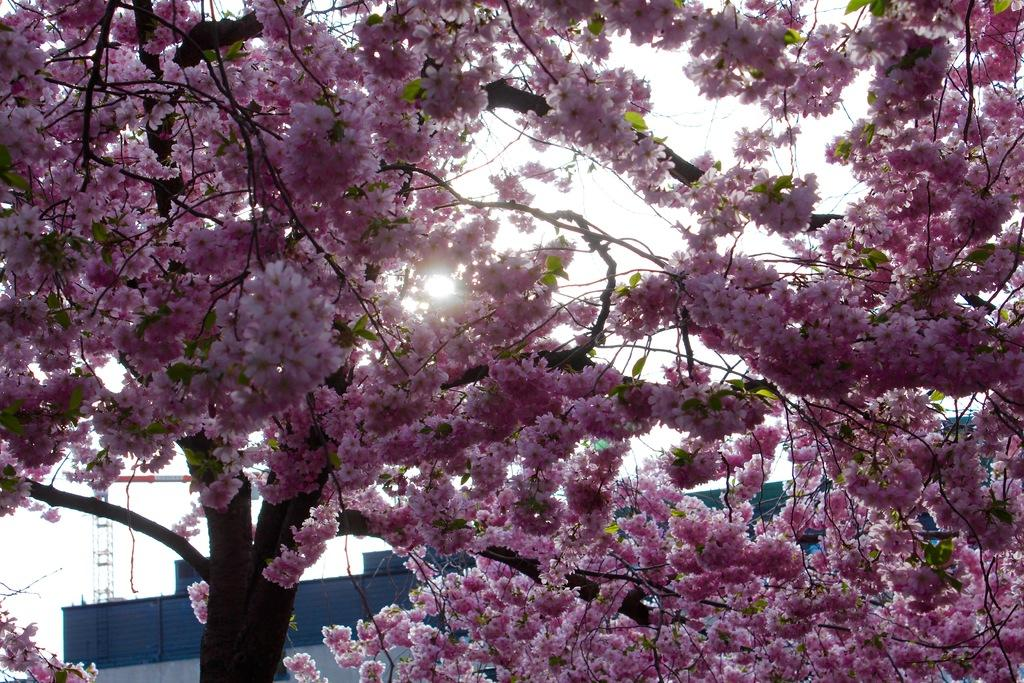What type of tree is present in the image? There is a tree with flowers in the image. What can be seen in the background of the image? There is a building and a rod in the background of the image. What is visible in the sky in the image? The sky is visible in the background of the image. What type of harmony can be heard in the image? There is no audible sound in the image, so it is not possible to determine the type of harmony present. 